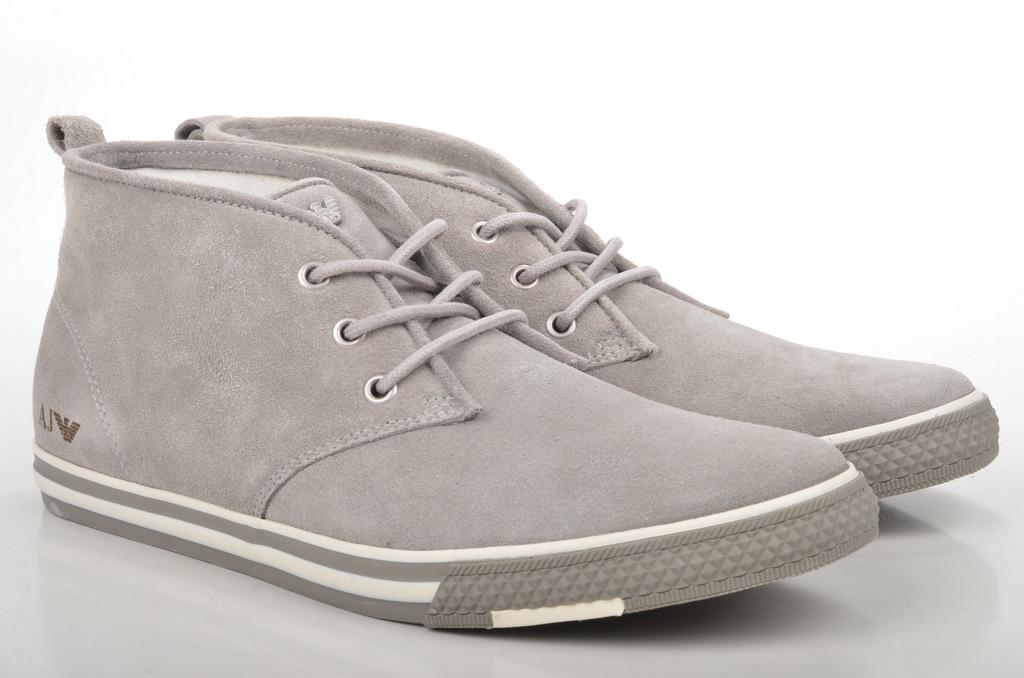What type of object is in the image? There is a pair of shoes in the image. What can be seen in the background of the image? The background of the image is white. How many women are present in the image? There is no mention of women in the image, as it only features a pair of shoes and a white background. 